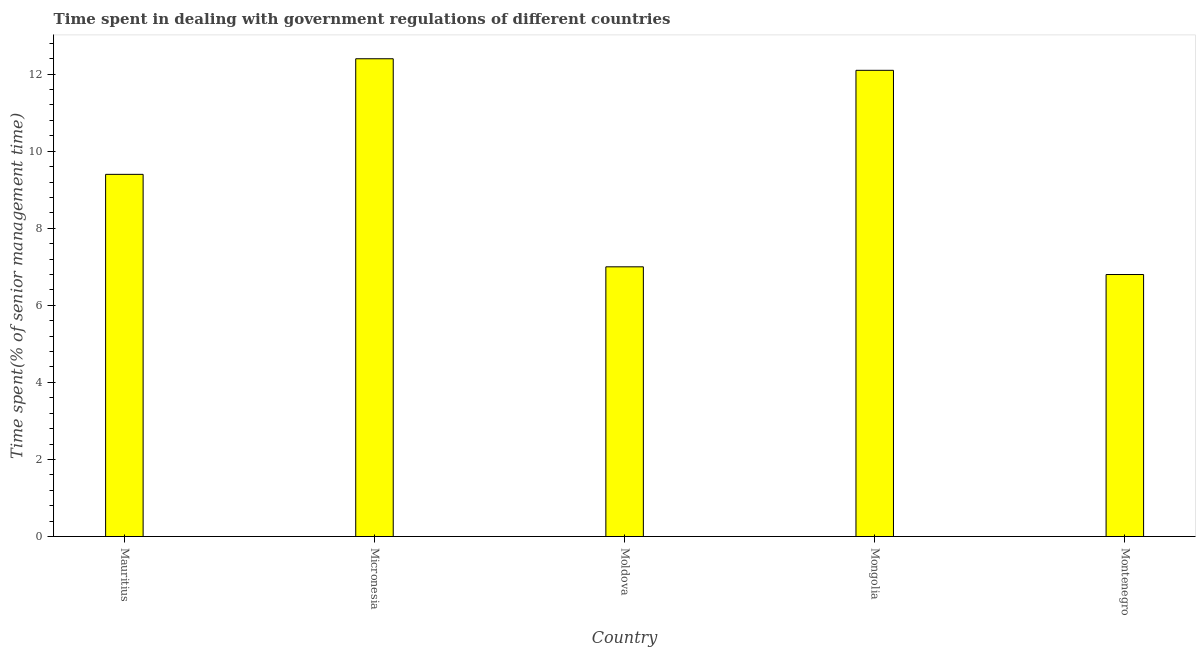Does the graph contain any zero values?
Provide a succinct answer. No. What is the title of the graph?
Make the answer very short. Time spent in dealing with government regulations of different countries. What is the label or title of the X-axis?
Keep it short and to the point. Country. What is the label or title of the Y-axis?
Keep it short and to the point. Time spent(% of senior management time). Across all countries, what is the minimum time spent in dealing with government regulations?
Provide a short and direct response. 6.8. In which country was the time spent in dealing with government regulations maximum?
Offer a terse response. Micronesia. In which country was the time spent in dealing with government regulations minimum?
Ensure brevity in your answer.  Montenegro. What is the sum of the time spent in dealing with government regulations?
Keep it short and to the point. 47.7. What is the average time spent in dealing with government regulations per country?
Keep it short and to the point. 9.54. What is the median time spent in dealing with government regulations?
Keep it short and to the point. 9.4. In how many countries, is the time spent in dealing with government regulations greater than 1.2 %?
Your answer should be compact. 5. What is the ratio of the time spent in dealing with government regulations in Mauritius to that in Moldova?
Ensure brevity in your answer.  1.34. Is the time spent in dealing with government regulations in Mongolia less than that in Montenegro?
Offer a very short reply. No. Is the difference between the time spent in dealing with government regulations in Micronesia and Moldova greater than the difference between any two countries?
Your answer should be very brief. No. What is the difference between the highest and the second highest time spent in dealing with government regulations?
Provide a short and direct response. 0.3. What is the difference between the highest and the lowest time spent in dealing with government regulations?
Provide a succinct answer. 5.6. How many bars are there?
Keep it short and to the point. 5. Are the values on the major ticks of Y-axis written in scientific E-notation?
Offer a very short reply. No. What is the Time spent(% of senior management time) of Mauritius?
Your answer should be compact. 9.4. What is the difference between the Time spent(% of senior management time) in Mauritius and Mongolia?
Ensure brevity in your answer.  -2.7. What is the difference between the Time spent(% of senior management time) in Mauritius and Montenegro?
Ensure brevity in your answer.  2.6. What is the difference between the Time spent(% of senior management time) in Micronesia and Montenegro?
Keep it short and to the point. 5.6. What is the difference between the Time spent(% of senior management time) in Moldova and Mongolia?
Offer a terse response. -5.1. What is the difference between the Time spent(% of senior management time) in Moldova and Montenegro?
Your answer should be very brief. 0.2. What is the ratio of the Time spent(% of senior management time) in Mauritius to that in Micronesia?
Give a very brief answer. 0.76. What is the ratio of the Time spent(% of senior management time) in Mauritius to that in Moldova?
Your answer should be compact. 1.34. What is the ratio of the Time spent(% of senior management time) in Mauritius to that in Mongolia?
Ensure brevity in your answer.  0.78. What is the ratio of the Time spent(% of senior management time) in Mauritius to that in Montenegro?
Give a very brief answer. 1.38. What is the ratio of the Time spent(% of senior management time) in Micronesia to that in Moldova?
Your answer should be very brief. 1.77. What is the ratio of the Time spent(% of senior management time) in Micronesia to that in Montenegro?
Offer a very short reply. 1.82. What is the ratio of the Time spent(% of senior management time) in Moldova to that in Mongolia?
Ensure brevity in your answer.  0.58. What is the ratio of the Time spent(% of senior management time) in Mongolia to that in Montenegro?
Offer a very short reply. 1.78. 